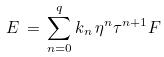<formula> <loc_0><loc_0><loc_500><loc_500>E \, = \, \sum _ { n = 0 } ^ { q } k _ { n } \, \eta ^ { n } \tau ^ { n + 1 } F</formula> 